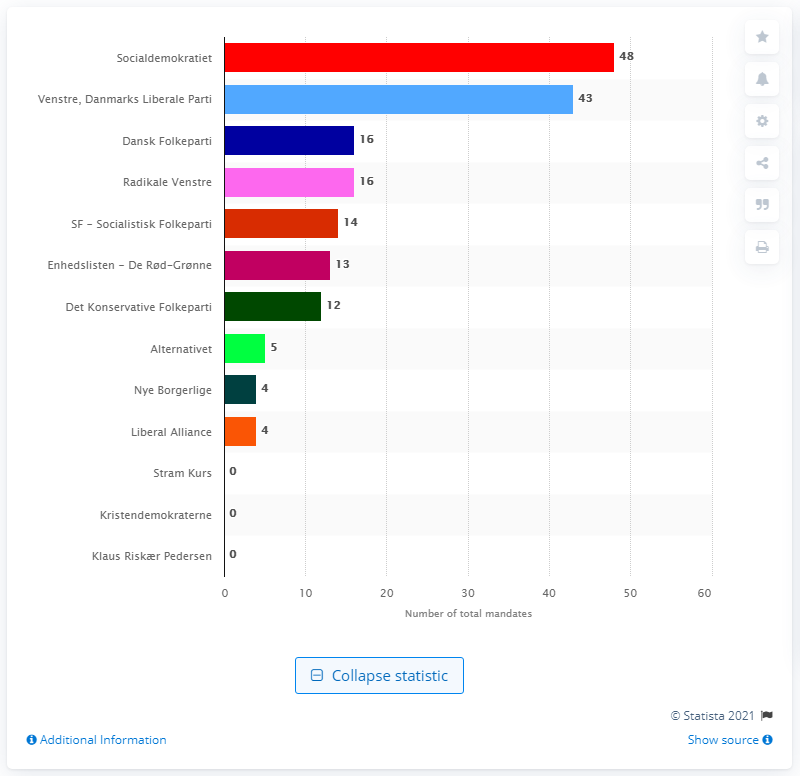List a handful of essential elements in this visual. Dansk Folkeparti and Radikale Venstre won a total of 16 mandates in the election. Venstre received 43 mandates in the most recent election. Nye Borgerlige was represented in the Danish Parliament for the first time in 2019. 